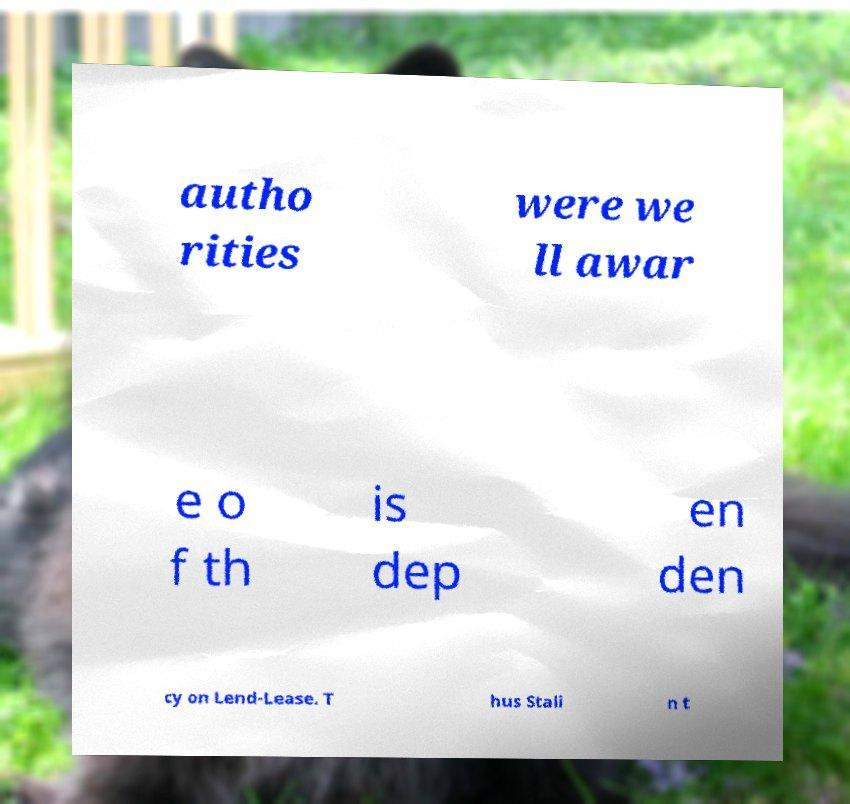Can you read and provide the text displayed in the image?This photo seems to have some interesting text. Can you extract and type it out for me? autho rities were we ll awar e o f th is dep en den cy on Lend-Lease. T hus Stali n t 